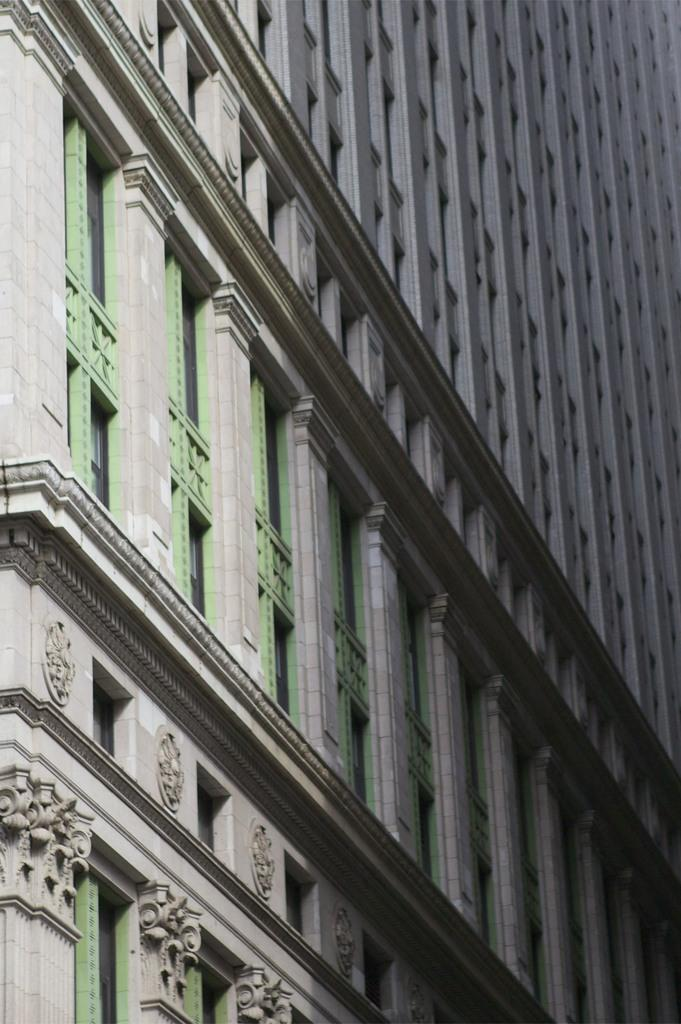What is the main subject of the picture? The main subject of the picture is a building. What specific features can be observed on the building? The building has windows and a sculpture. What type of popcorn can be seen on the building in the image? There is no popcorn present on the building in the image. Can you tell me how many people are standing near the building in the image? The image does not show any people near the building, so it is not possible to determine the number of people present. 